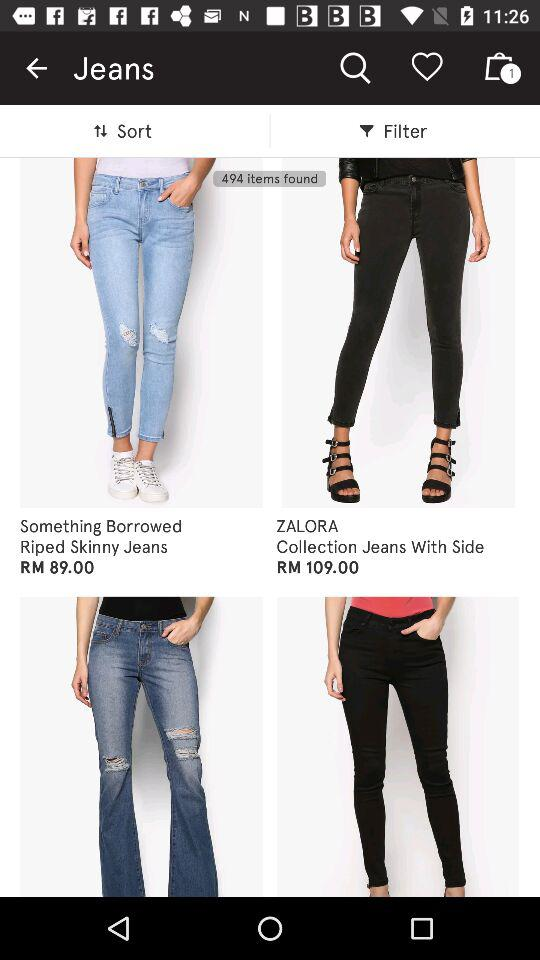How much more expensive is the second item than the first item?
Answer the question using a single word or phrase. RM 20.00 